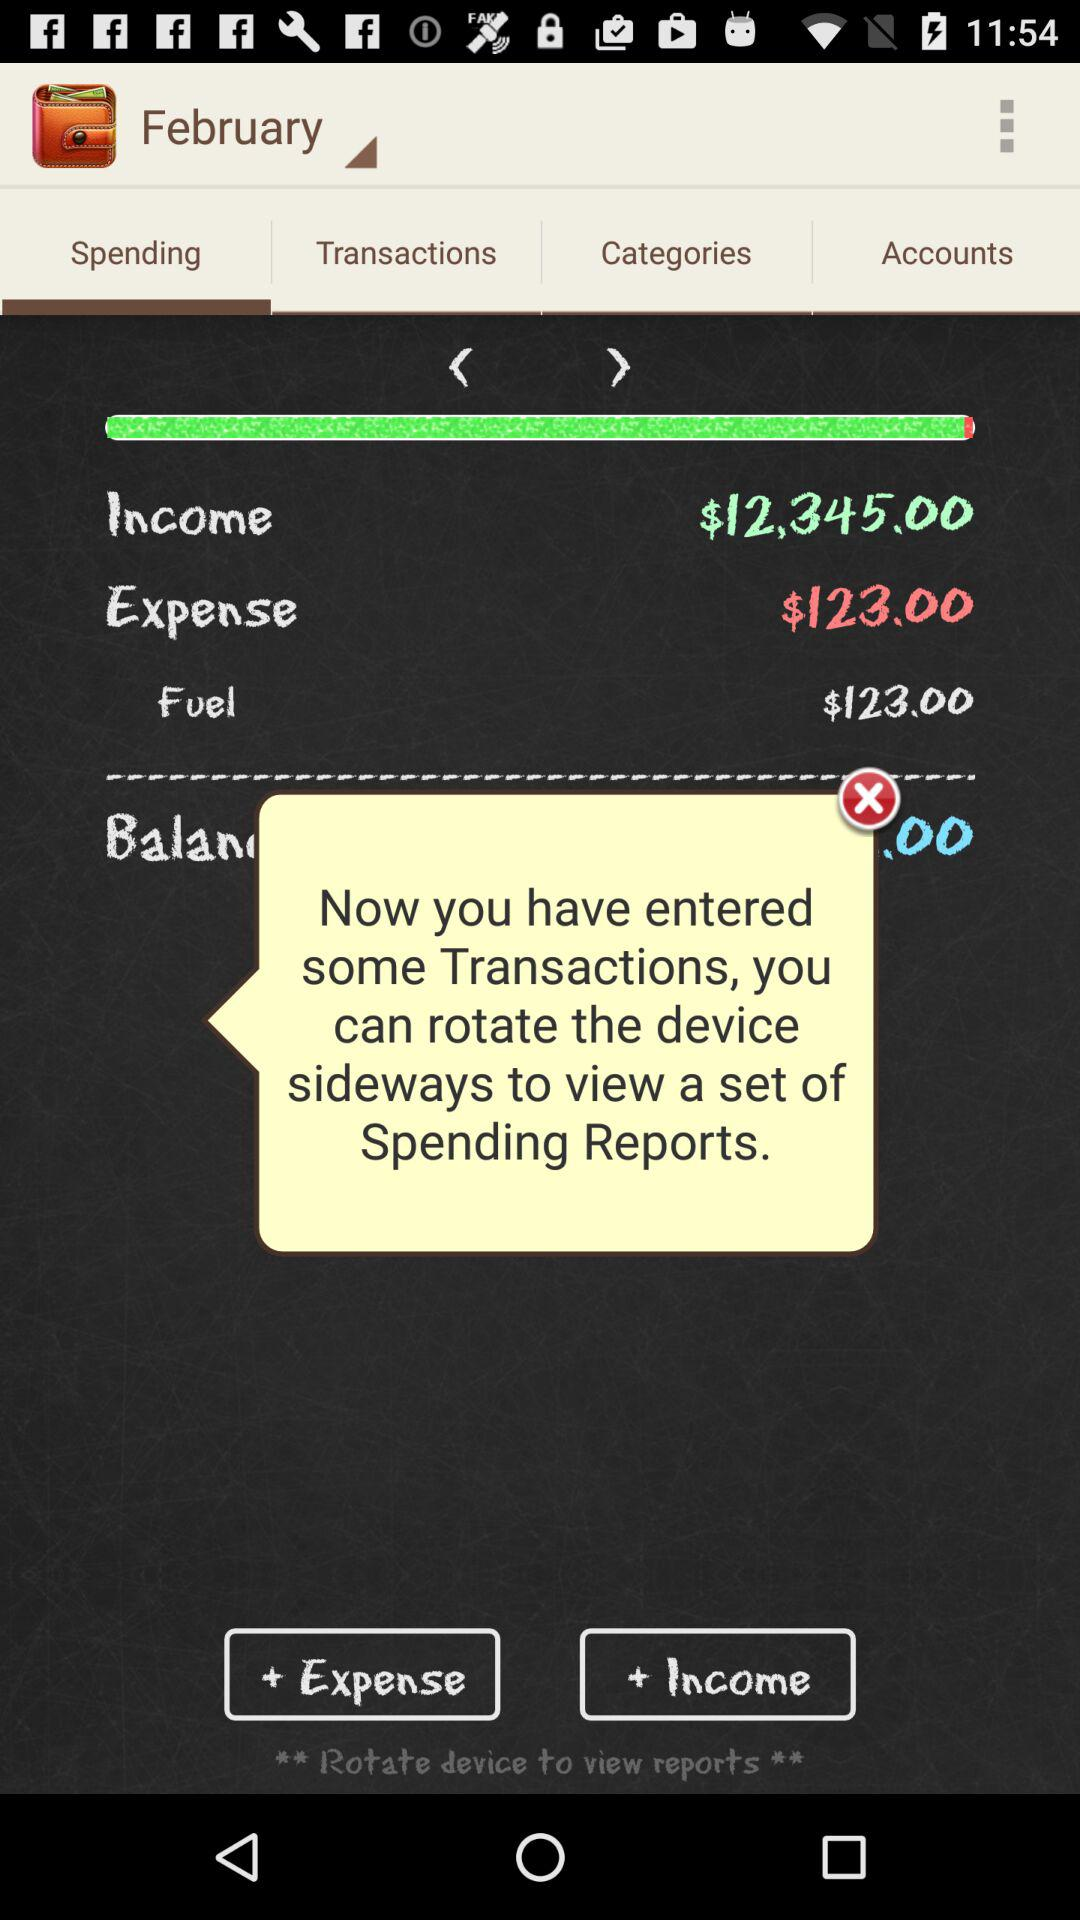When was the last transaction made?
When the provided information is insufficient, respond with <no answer>. <no answer> 